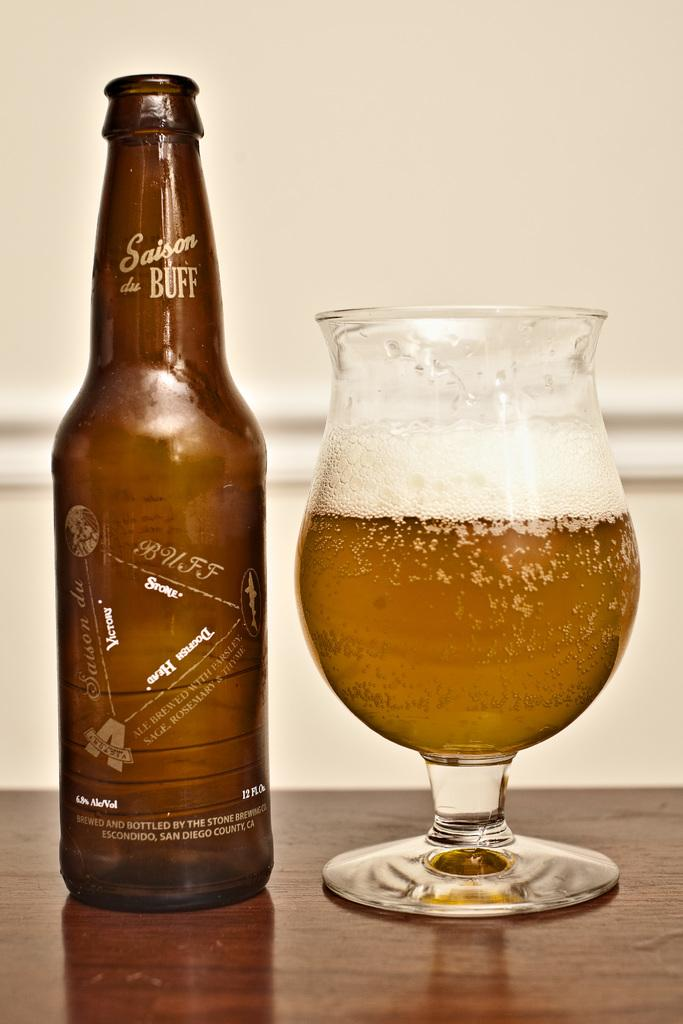<image>
Offer a succinct explanation of the picture presented. A bottle of Saison du Buff sits on a table next to a half-full glass. 